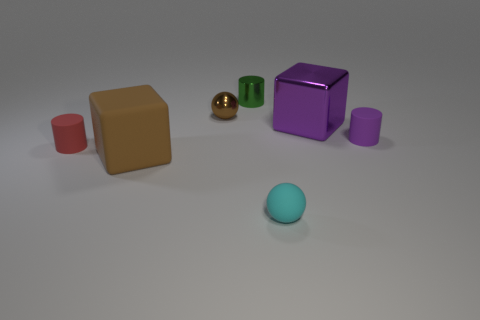Is the material of the tiny red thing the same as the big purple thing?
Ensure brevity in your answer.  No. There is a large brown thing that is made of the same material as the tiny cyan ball; what shape is it?
Your response must be concise. Cube. Is the number of small cylinders less than the number of tiny brown things?
Make the answer very short. No. What is the material of the cylinder that is both on the left side of the tiny cyan rubber sphere and in front of the shiny ball?
Keep it short and to the point. Rubber. What is the size of the rubber cylinder that is behind the tiny red rubber cylinder in front of the rubber cylinder to the right of the small green metal thing?
Make the answer very short. Small. Is the shape of the brown matte thing the same as the purple thing to the left of the small purple thing?
Keep it short and to the point. Yes. What number of objects are right of the cyan rubber sphere and behind the tiny purple cylinder?
Ensure brevity in your answer.  1. How many blue things are small objects or shiny cylinders?
Your answer should be very brief. 0. Do the cylinder that is to the right of the cyan object and the block that is to the right of the brown cube have the same color?
Your answer should be compact. Yes. There is a block that is in front of the tiny thing that is right of the block behind the small red cylinder; what color is it?
Give a very brief answer. Brown. 